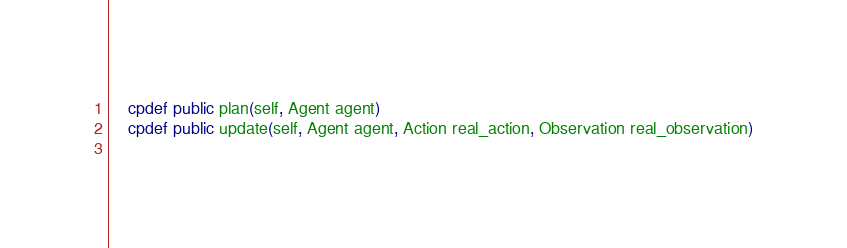<code> <loc_0><loc_0><loc_500><loc_500><_Cython_>    cpdef public plan(self, Agent agent)
    cpdef public update(self, Agent agent, Action real_action, Observation real_observation)
    
</code> 